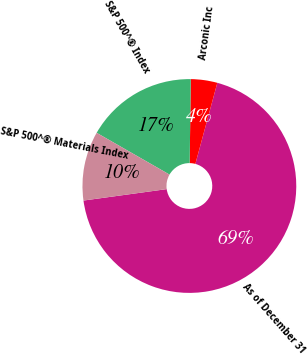<chart> <loc_0><loc_0><loc_500><loc_500><pie_chart><fcel>As of December 31<fcel>Arconic Inc<fcel>S&P 500^® Index<fcel>S&P 500^® Materials Index<nl><fcel>68.61%<fcel>4.0%<fcel>16.92%<fcel>10.46%<nl></chart> 